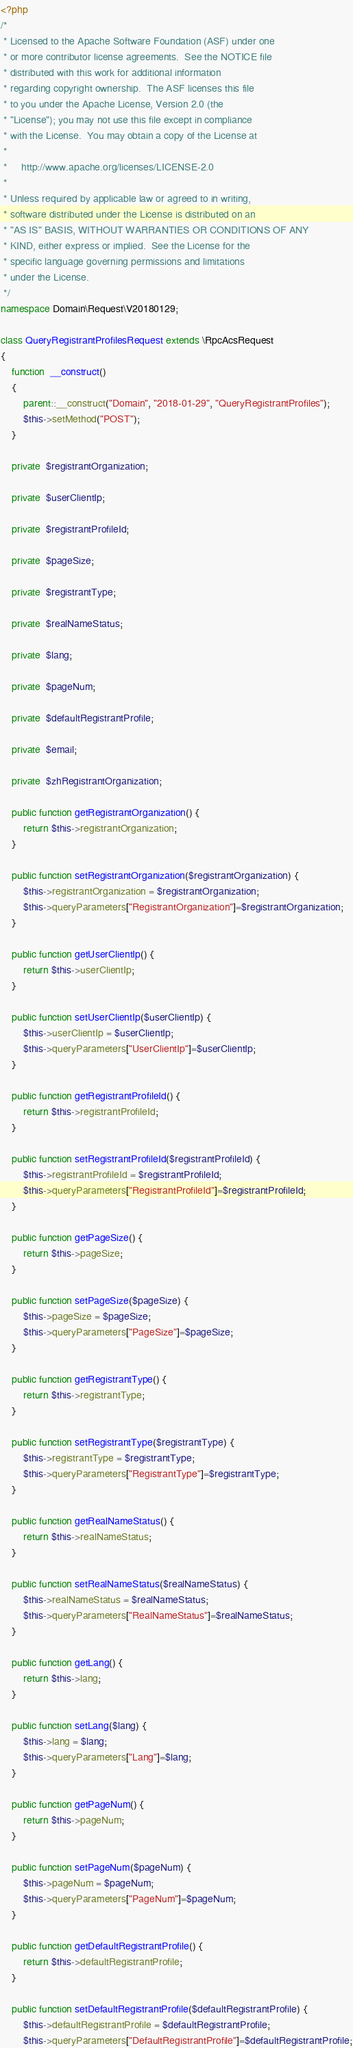Convert code to text. <code><loc_0><loc_0><loc_500><loc_500><_PHP_><?php
/*
 * Licensed to the Apache Software Foundation (ASF) under one
 * or more contributor license agreements.  See the NOTICE file
 * distributed with this work for additional information
 * regarding copyright ownership.  The ASF licenses this file
 * to you under the Apache License, Version 2.0 (the
 * "License"); you may not use this file except in compliance
 * with the License.  You may obtain a copy of the License at
 *
 *     http://www.apache.org/licenses/LICENSE-2.0
 *
 * Unless required by applicable law or agreed to in writing,
 * software distributed under the License is distributed on an
 * "AS IS" BASIS, WITHOUT WARRANTIES OR CONDITIONS OF ANY
 * KIND, either express or implied.  See the License for the
 * specific language governing permissions and limitations
 * under the License.
 */
namespace Domain\Request\V20180129;

class QueryRegistrantProfilesRequest extends \RpcAcsRequest
{
	function  __construct()
	{
		parent::__construct("Domain", "2018-01-29", "QueryRegistrantProfiles");
		$this->setMethod("POST");
	}

	private  $registrantOrganization;

	private  $userClientIp;

	private  $registrantProfileId;

	private  $pageSize;

	private  $registrantType;

	private  $realNameStatus;

	private  $lang;

	private  $pageNum;

	private  $defaultRegistrantProfile;

	private  $email;

	private  $zhRegistrantOrganization;

	public function getRegistrantOrganization() {
		return $this->registrantOrganization;
	}

	public function setRegistrantOrganization($registrantOrganization) {
		$this->registrantOrganization = $registrantOrganization;
		$this->queryParameters["RegistrantOrganization"]=$registrantOrganization;
	}

	public function getUserClientIp() {
		return $this->userClientIp;
	}

	public function setUserClientIp($userClientIp) {
		$this->userClientIp = $userClientIp;
		$this->queryParameters["UserClientIp"]=$userClientIp;
	}

	public function getRegistrantProfileId() {
		return $this->registrantProfileId;
	}

	public function setRegistrantProfileId($registrantProfileId) {
		$this->registrantProfileId = $registrantProfileId;
		$this->queryParameters["RegistrantProfileId"]=$registrantProfileId;
	}

	public function getPageSize() {
		return $this->pageSize;
	}

	public function setPageSize($pageSize) {
		$this->pageSize = $pageSize;
		$this->queryParameters["PageSize"]=$pageSize;
	}

	public function getRegistrantType() {
		return $this->registrantType;
	}

	public function setRegistrantType($registrantType) {
		$this->registrantType = $registrantType;
		$this->queryParameters["RegistrantType"]=$registrantType;
	}

	public function getRealNameStatus() {
		return $this->realNameStatus;
	}

	public function setRealNameStatus($realNameStatus) {
		$this->realNameStatus = $realNameStatus;
		$this->queryParameters["RealNameStatus"]=$realNameStatus;
	}

	public function getLang() {
		return $this->lang;
	}

	public function setLang($lang) {
		$this->lang = $lang;
		$this->queryParameters["Lang"]=$lang;
	}

	public function getPageNum() {
		return $this->pageNum;
	}

	public function setPageNum($pageNum) {
		$this->pageNum = $pageNum;
		$this->queryParameters["PageNum"]=$pageNum;
	}

	public function getDefaultRegistrantProfile() {
		return $this->defaultRegistrantProfile;
	}

	public function setDefaultRegistrantProfile($defaultRegistrantProfile) {
		$this->defaultRegistrantProfile = $defaultRegistrantProfile;
		$this->queryParameters["DefaultRegistrantProfile"]=$defaultRegistrantProfile;</code> 